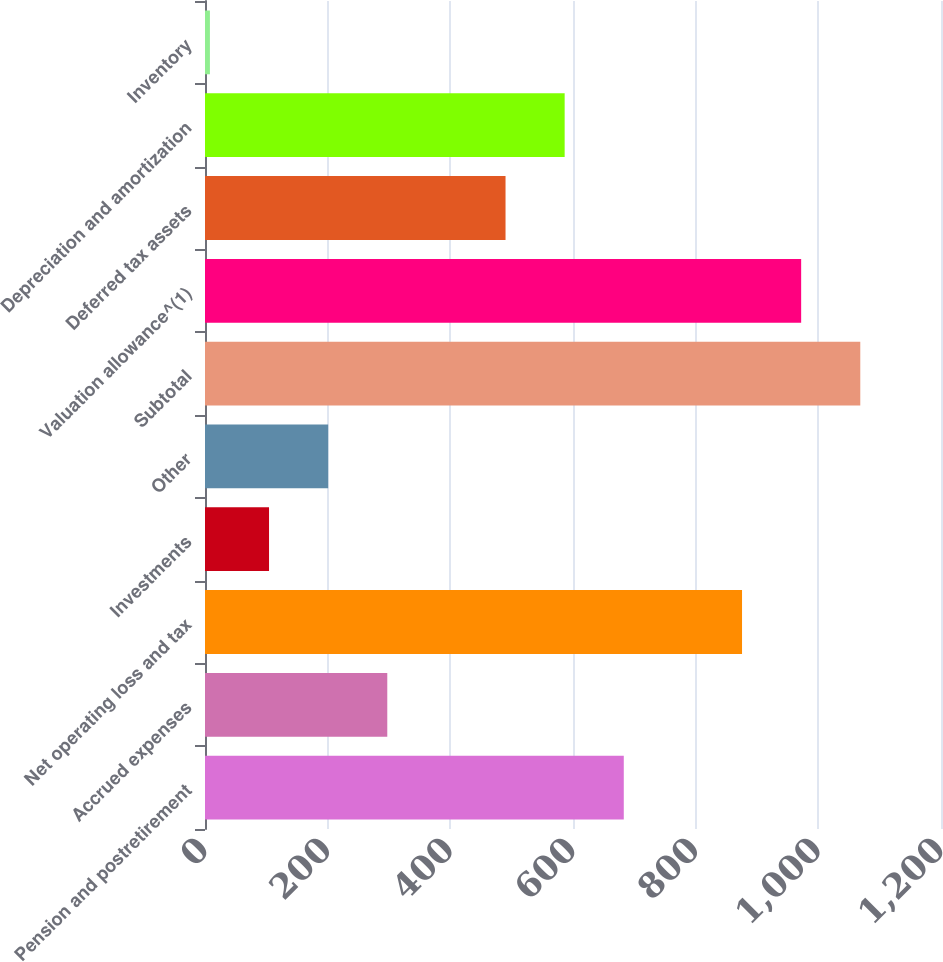Convert chart to OTSL. <chart><loc_0><loc_0><loc_500><loc_500><bar_chart><fcel>Pension and postretirement<fcel>Accrued expenses<fcel>Net operating loss and tax<fcel>Investments<fcel>Other<fcel>Subtotal<fcel>Valuation allowance^(1)<fcel>Deferred tax assets<fcel>Depreciation and amortization<fcel>Inventory<nl><fcel>682.8<fcel>297.2<fcel>875.6<fcel>104.4<fcel>200.8<fcel>1068.4<fcel>972<fcel>490<fcel>586.4<fcel>8<nl></chart> 